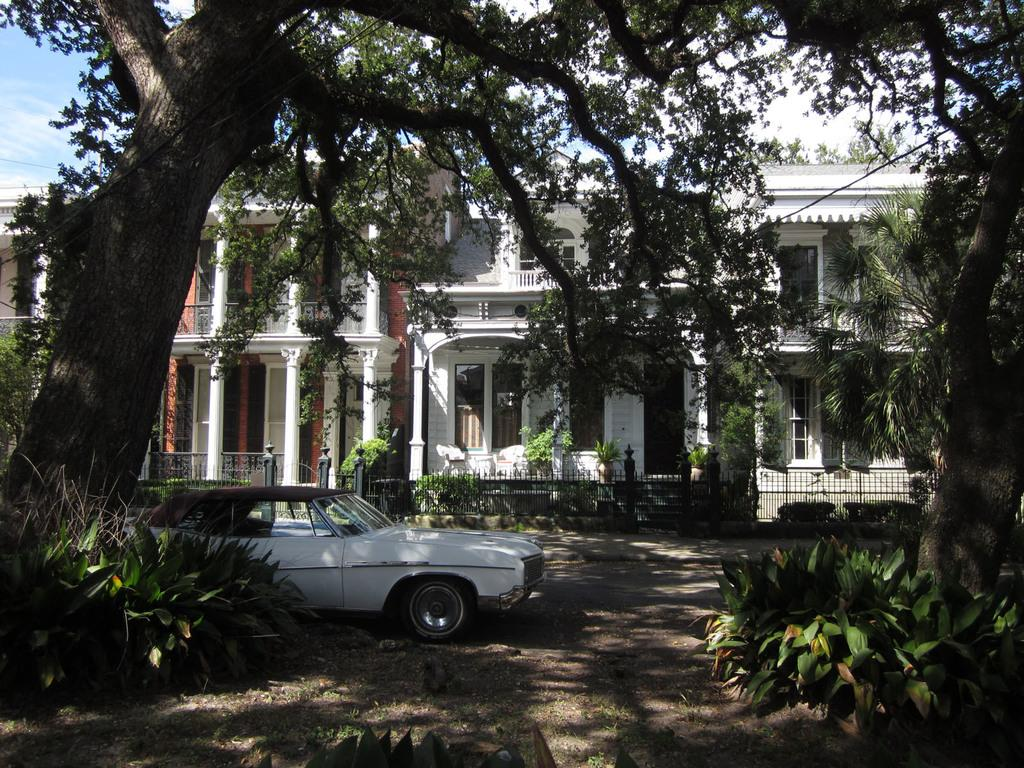What types of vegetation can be seen in the image? There are plants and trees in the image. What man-made object is visible in the image? There is a car in the image. What architectural features can be seen in the background of the image? In the background of the image, there is a fence, railings, pillars, and buildings. What natural element is visible in the background of the image? In the background of the image, there is sky. How many snakes are slithering around the car in the image? There are no snakes present in the image; it only features plants, trees, a car, and various architectural and natural elements in the background. 